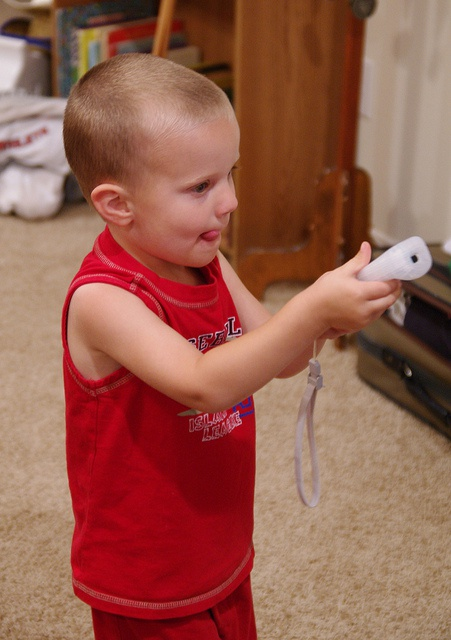Describe the objects in this image and their specific colors. I can see people in gray, brown, maroon, and salmon tones and remote in gray, lightgray, darkgray, and pink tones in this image. 